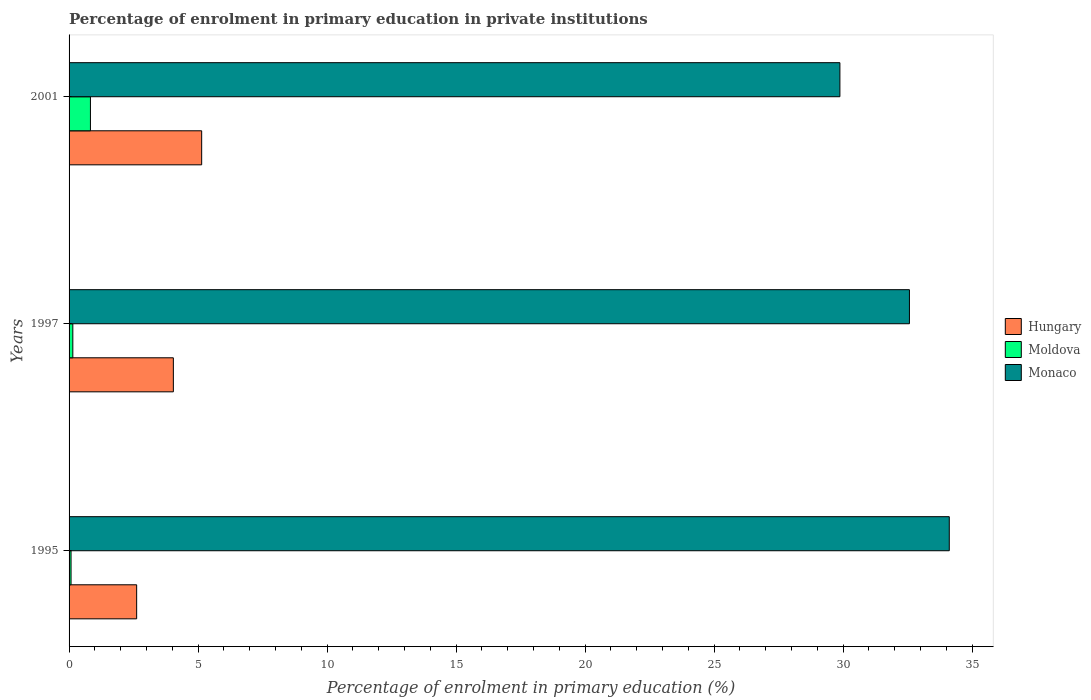How many groups of bars are there?
Your answer should be very brief. 3. How many bars are there on the 3rd tick from the top?
Offer a very short reply. 3. What is the label of the 1st group of bars from the top?
Provide a succinct answer. 2001. In how many cases, is the number of bars for a given year not equal to the number of legend labels?
Make the answer very short. 0. What is the percentage of enrolment in primary education in Moldova in 1997?
Provide a short and direct response. 0.15. Across all years, what is the maximum percentage of enrolment in primary education in Hungary?
Offer a very short reply. 5.14. Across all years, what is the minimum percentage of enrolment in primary education in Monaco?
Your response must be concise. 29.87. In which year was the percentage of enrolment in primary education in Monaco maximum?
Provide a succinct answer. 1995. In which year was the percentage of enrolment in primary education in Moldova minimum?
Provide a short and direct response. 1995. What is the total percentage of enrolment in primary education in Monaco in the graph?
Provide a short and direct response. 96.56. What is the difference between the percentage of enrolment in primary education in Moldova in 1995 and that in 2001?
Give a very brief answer. -0.75. What is the difference between the percentage of enrolment in primary education in Hungary in 1997 and the percentage of enrolment in primary education in Moldova in 1995?
Offer a terse response. 3.96. What is the average percentage of enrolment in primary education in Monaco per year?
Your answer should be compact. 32.19. In the year 1997, what is the difference between the percentage of enrolment in primary education in Monaco and percentage of enrolment in primary education in Hungary?
Keep it short and to the point. 28.53. In how many years, is the percentage of enrolment in primary education in Hungary greater than 31 %?
Give a very brief answer. 0. What is the ratio of the percentage of enrolment in primary education in Monaco in 1997 to that in 2001?
Your answer should be very brief. 1.09. Is the percentage of enrolment in primary education in Moldova in 1995 less than that in 1997?
Your answer should be compact. Yes. Is the difference between the percentage of enrolment in primary education in Monaco in 1995 and 2001 greater than the difference between the percentage of enrolment in primary education in Hungary in 1995 and 2001?
Offer a very short reply. Yes. What is the difference between the highest and the second highest percentage of enrolment in primary education in Monaco?
Make the answer very short. 1.54. What is the difference between the highest and the lowest percentage of enrolment in primary education in Monaco?
Your answer should be very brief. 4.24. Is the sum of the percentage of enrolment in primary education in Moldova in 1997 and 2001 greater than the maximum percentage of enrolment in primary education in Hungary across all years?
Offer a terse response. No. What does the 2nd bar from the top in 1995 represents?
Provide a short and direct response. Moldova. What does the 2nd bar from the bottom in 1995 represents?
Ensure brevity in your answer.  Moldova. Is it the case that in every year, the sum of the percentage of enrolment in primary education in Moldova and percentage of enrolment in primary education in Monaco is greater than the percentage of enrolment in primary education in Hungary?
Make the answer very short. Yes. Are all the bars in the graph horizontal?
Your response must be concise. Yes. How many years are there in the graph?
Ensure brevity in your answer.  3. Are the values on the major ticks of X-axis written in scientific E-notation?
Your answer should be very brief. No. How many legend labels are there?
Your answer should be compact. 3. How are the legend labels stacked?
Your answer should be very brief. Vertical. What is the title of the graph?
Provide a succinct answer. Percentage of enrolment in primary education in private institutions. Does "Belize" appear as one of the legend labels in the graph?
Offer a terse response. No. What is the label or title of the X-axis?
Provide a succinct answer. Percentage of enrolment in primary education (%). What is the label or title of the Y-axis?
Keep it short and to the point. Years. What is the Percentage of enrolment in primary education (%) in Hungary in 1995?
Give a very brief answer. 2.62. What is the Percentage of enrolment in primary education (%) of Moldova in 1995?
Give a very brief answer. 0.08. What is the Percentage of enrolment in primary education (%) of Monaco in 1995?
Keep it short and to the point. 34.11. What is the Percentage of enrolment in primary education (%) of Hungary in 1997?
Your answer should be very brief. 4.04. What is the Percentage of enrolment in primary education (%) of Moldova in 1997?
Offer a terse response. 0.15. What is the Percentage of enrolment in primary education (%) of Monaco in 1997?
Offer a very short reply. 32.57. What is the Percentage of enrolment in primary education (%) of Hungary in 2001?
Your answer should be very brief. 5.14. What is the Percentage of enrolment in primary education (%) in Moldova in 2001?
Offer a very short reply. 0.83. What is the Percentage of enrolment in primary education (%) in Monaco in 2001?
Your answer should be very brief. 29.87. Across all years, what is the maximum Percentage of enrolment in primary education (%) in Hungary?
Offer a terse response. 5.14. Across all years, what is the maximum Percentage of enrolment in primary education (%) of Moldova?
Your answer should be compact. 0.83. Across all years, what is the maximum Percentage of enrolment in primary education (%) of Monaco?
Make the answer very short. 34.11. Across all years, what is the minimum Percentage of enrolment in primary education (%) in Hungary?
Your response must be concise. 2.62. Across all years, what is the minimum Percentage of enrolment in primary education (%) of Moldova?
Your response must be concise. 0.08. Across all years, what is the minimum Percentage of enrolment in primary education (%) of Monaco?
Provide a short and direct response. 29.87. What is the total Percentage of enrolment in primary education (%) of Hungary in the graph?
Ensure brevity in your answer.  11.8. What is the total Percentage of enrolment in primary education (%) of Moldova in the graph?
Give a very brief answer. 1.05. What is the total Percentage of enrolment in primary education (%) of Monaco in the graph?
Your response must be concise. 96.56. What is the difference between the Percentage of enrolment in primary education (%) in Hungary in 1995 and that in 1997?
Provide a short and direct response. -1.42. What is the difference between the Percentage of enrolment in primary education (%) in Moldova in 1995 and that in 1997?
Ensure brevity in your answer.  -0.07. What is the difference between the Percentage of enrolment in primary education (%) of Monaco in 1995 and that in 1997?
Ensure brevity in your answer.  1.54. What is the difference between the Percentage of enrolment in primary education (%) of Hungary in 1995 and that in 2001?
Your answer should be compact. -2.52. What is the difference between the Percentage of enrolment in primary education (%) in Moldova in 1995 and that in 2001?
Ensure brevity in your answer.  -0.75. What is the difference between the Percentage of enrolment in primary education (%) in Monaco in 1995 and that in 2001?
Give a very brief answer. 4.24. What is the difference between the Percentage of enrolment in primary education (%) in Hungary in 1997 and that in 2001?
Keep it short and to the point. -1.1. What is the difference between the Percentage of enrolment in primary education (%) in Moldova in 1997 and that in 2001?
Provide a short and direct response. -0.68. What is the difference between the Percentage of enrolment in primary education (%) of Monaco in 1997 and that in 2001?
Offer a very short reply. 2.69. What is the difference between the Percentage of enrolment in primary education (%) of Hungary in 1995 and the Percentage of enrolment in primary education (%) of Moldova in 1997?
Make the answer very short. 2.47. What is the difference between the Percentage of enrolment in primary education (%) of Hungary in 1995 and the Percentage of enrolment in primary education (%) of Monaco in 1997?
Your response must be concise. -29.95. What is the difference between the Percentage of enrolment in primary education (%) of Moldova in 1995 and the Percentage of enrolment in primary education (%) of Monaco in 1997?
Your answer should be very brief. -32.49. What is the difference between the Percentage of enrolment in primary education (%) of Hungary in 1995 and the Percentage of enrolment in primary education (%) of Moldova in 2001?
Provide a succinct answer. 1.79. What is the difference between the Percentage of enrolment in primary education (%) of Hungary in 1995 and the Percentage of enrolment in primary education (%) of Monaco in 2001?
Make the answer very short. -27.25. What is the difference between the Percentage of enrolment in primary education (%) in Moldova in 1995 and the Percentage of enrolment in primary education (%) in Monaco in 2001?
Provide a short and direct response. -29.8. What is the difference between the Percentage of enrolment in primary education (%) in Hungary in 1997 and the Percentage of enrolment in primary education (%) in Moldova in 2001?
Offer a very short reply. 3.21. What is the difference between the Percentage of enrolment in primary education (%) of Hungary in 1997 and the Percentage of enrolment in primary education (%) of Monaco in 2001?
Offer a terse response. -25.83. What is the difference between the Percentage of enrolment in primary education (%) in Moldova in 1997 and the Percentage of enrolment in primary education (%) in Monaco in 2001?
Offer a terse response. -29.73. What is the average Percentage of enrolment in primary education (%) of Hungary per year?
Make the answer very short. 3.93. What is the average Percentage of enrolment in primary education (%) of Moldova per year?
Give a very brief answer. 0.35. What is the average Percentage of enrolment in primary education (%) of Monaco per year?
Ensure brevity in your answer.  32.19. In the year 1995, what is the difference between the Percentage of enrolment in primary education (%) in Hungary and Percentage of enrolment in primary education (%) in Moldova?
Your answer should be compact. 2.54. In the year 1995, what is the difference between the Percentage of enrolment in primary education (%) of Hungary and Percentage of enrolment in primary education (%) of Monaco?
Give a very brief answer. -31.49. In the year 1995, what is the difference between the Percentage of enrolment in primary education (%) in Moldova and Percentage of enrolment in primary education (%) in Monaco?
Give a very brief answer. -34.04. In the year 1997, what is the difference between the Percentage of enrolment in primary education (%) in Hungary and Percentage of enrolment in primary education (%) in Moldova?
Provide a short and direct response. 3.9. In the year 1997, what is the difference between the Percentage of enrolment in primary education (%) in Hungary and Percentage of enrolment in primary education (%) in Monaco?
Make the answer very short. -28.53. In the year 1997, what is the difference between the Percentage of enrolment in primary education (%) in Moldova and Percentage of enrolment in primary education (%) in Monaco?
Your answer should be compact. -32.42. In the year 2001, what is the difference between the Percentage of enrolment in primary education (%) in Hungary and Percentage of enrolment in primary education (%) in Moldova?
Give a very brief answer. 4.31. In the year 2001, what is the difference between the Percentage of enrolment in primary education (%) in Hungary and Percentage of enrolment in primary education (%) in Monaco?
Provide a short and direct response. -24.74. In the year 2001, what is the difference between the Percentage of enrolment in primary education (%) of Moldova and Percentage of enrolment in primary education (%) of Monaco?
Give a very brief answer. -29.05. What is the ratio of the Percentage of enrolment in primary education (%) of Hungary in 1995 to that in 1997?
Provide a short and direct response. 0.65. What is the ratio of the Percentage of enrolment in primary education (%) of Moldova in 1995 to that in 1997?
Provide a short and direct response. 0.53. What is the ratio of the Percentage of enrolment in primary education (%) of Monaco in 1995 to that in 1997?
Your answer should be very brief. 1.05. What is the ratio of the Percentage of enrolment in primary education (%) of Hungary in 1995 to that in 2001?
Your answer should be very brief. 0.51. What is the ratio of the Percentage of enrolment in primary education (%) in Moldova in 1995 to that in 2001?
Keep it short and to the point. 0.09. What is the ratio of the Percentage of enrolment in primary education (%) in Monaco in 1995 to that in 2001?
Make the answer very short. 1.14. What is the ratio of the Percentage of enrolment in primary education (%) in Hungary in 1997 to that in 2001?
Keep it short and to the point. 0.79. What is the ratio of the Percentage of enrolment in primary education (%) of Moldova in 1997 to that in 2001?
Offer a very short reply. 0.18. What is the ratio of the Percentage of enrolment in primary education (%) in Monaco in 1997 to that in 2001?
Give a very brief answer. 1.09. What is the difference between the highest and the second highest Percentage of enrolment in primary education (%) of Hungary?
Make the answer very short. 1.1. What is the difference between the highest and the second highest Percentage of enrolment in primary education (%) of Moldova?
Provide a succinct answer. 0.68. What is the difference between the highest and the second highest Percentage of enrolment in primary education (%) of Monaco?
Give a very brief answer. 1.54. What is the difference between the highest and the lowest Percentage of enrolment in primary education (%) of Hungary?
Provide a short and direct response. 2.52. What is the difference between the highest and the lowest Percentage of enrolment in primary education (%) in Moldova?
Give a very brief answer. 0.75. What is the difference between the highest and the lowest Percentage of enrolment in primary education (%) of Monaco?
Provide a short and direct response. 4.24. 